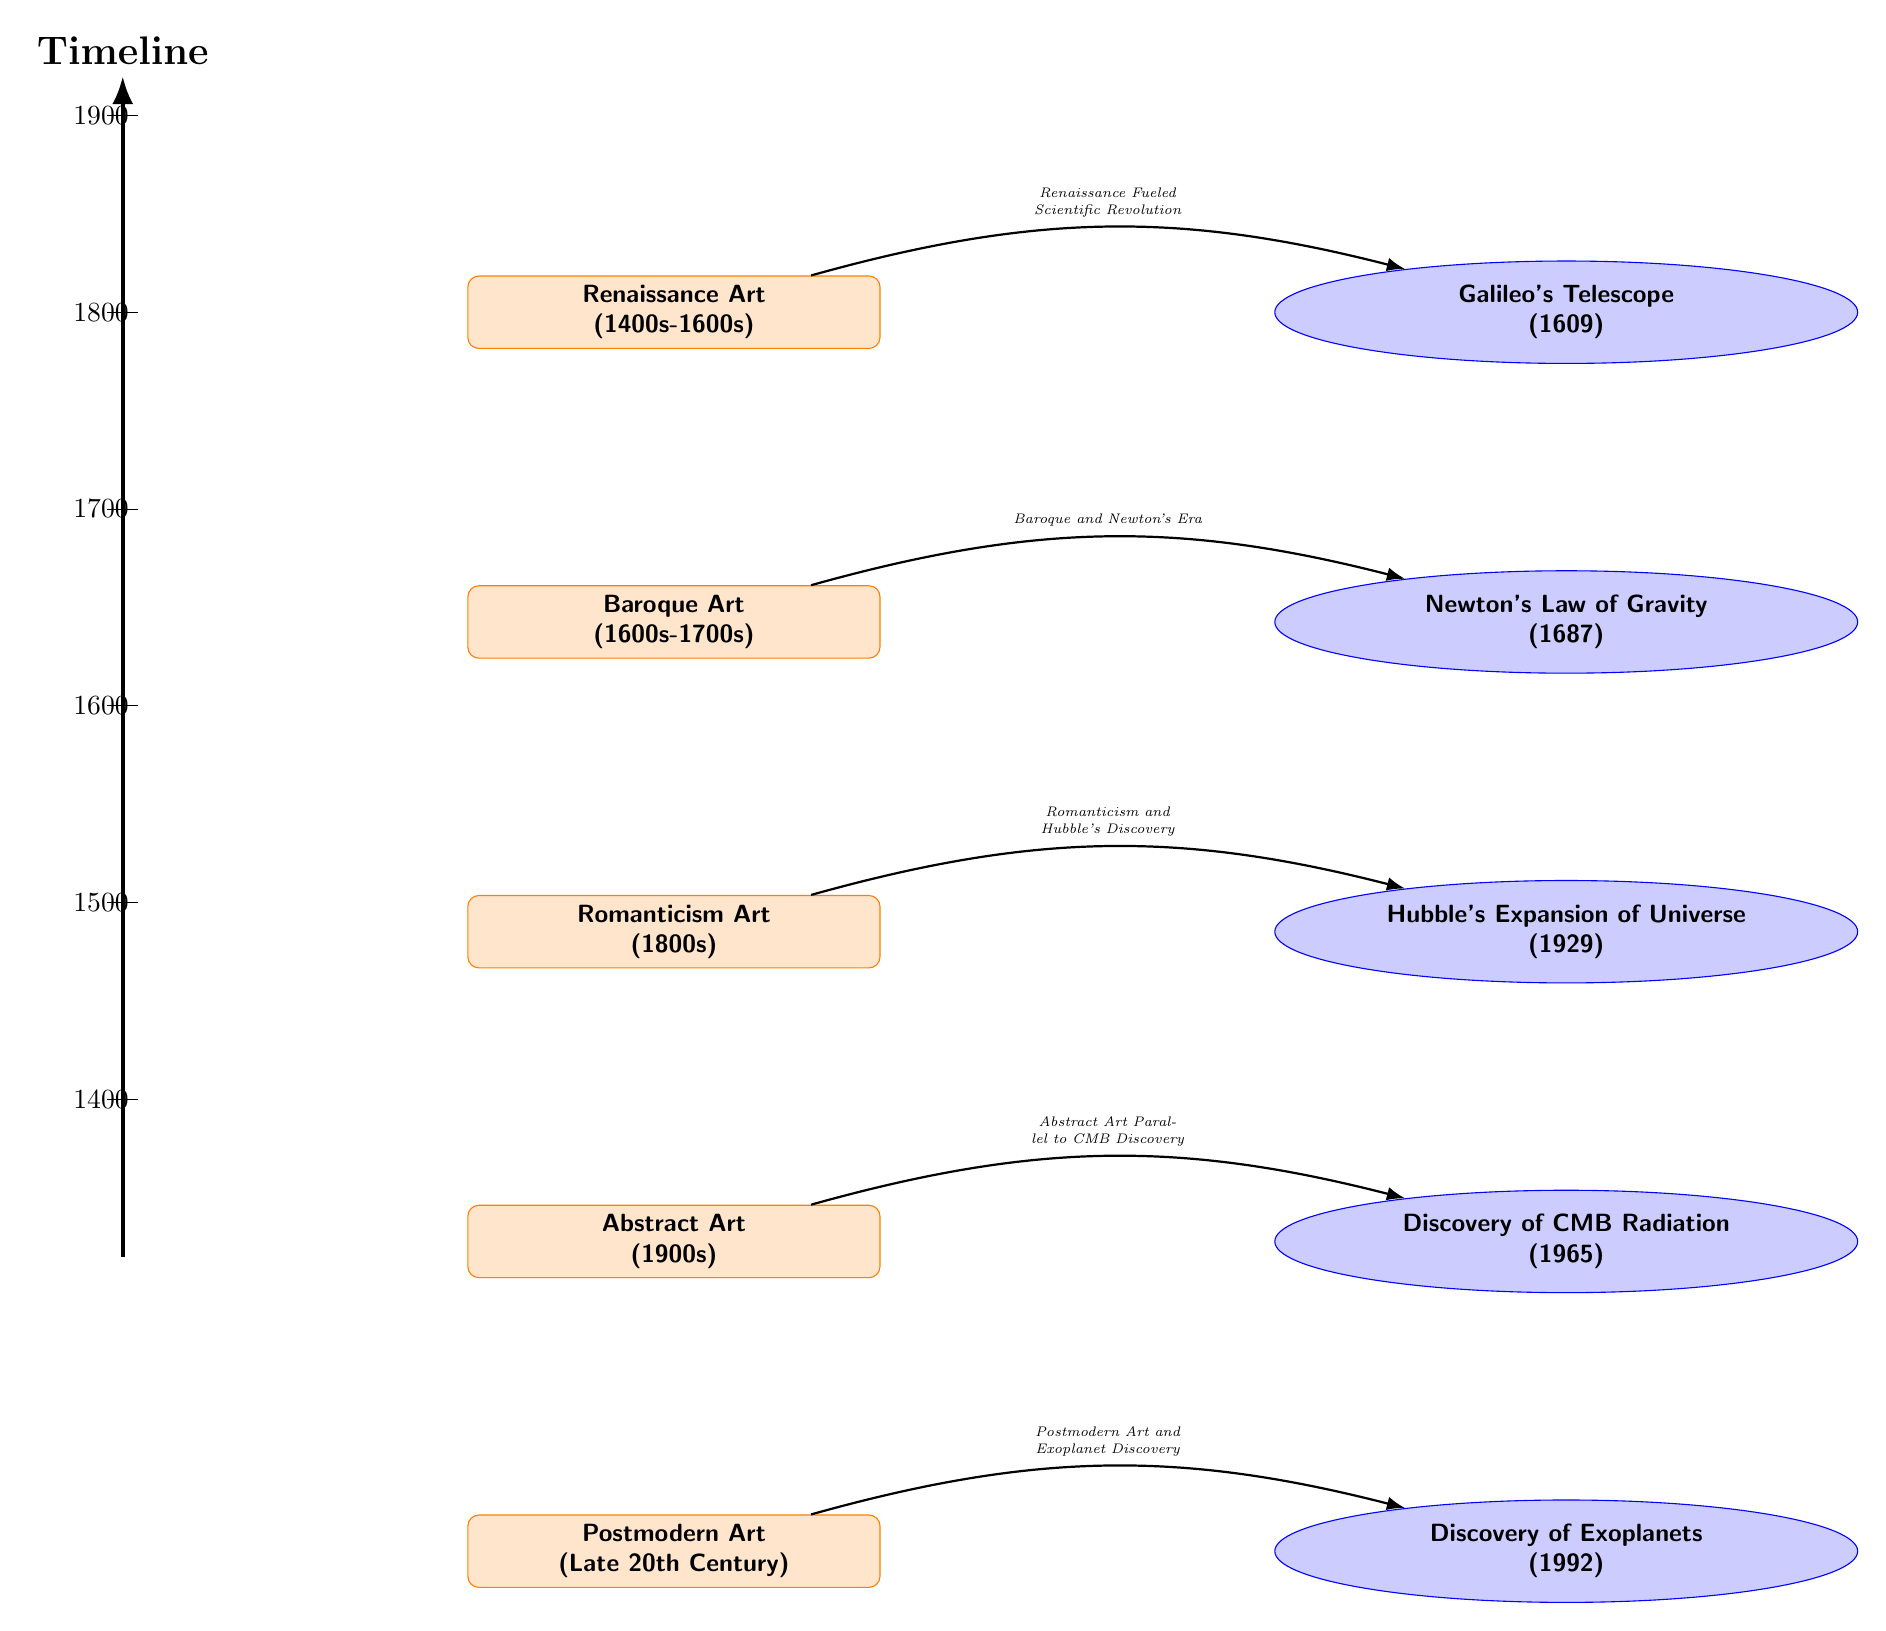What art movement corresponds with Galileo's Telescope? According to the diagram, Galileo's Telescope is connected to the Renaissance Art, which occurred from the 1400s to the 1600s. The edge labeled "Renaissance Fueled Scientific Revolution" indicates this relationship.
Answer: Renaissance Art What year was Newton's Law of Gravity discovered? The diagram specifies that Newton's Law of Gravity was discovered in 1687, which is directly indicated next to the corresponding astronomy node.
Answer: 1687 How many art movements are depicted in the diagram? There are a total of five art movement nodes listed in the diagram, which can be counted: Renaissance, Baroque, Romanticism, Abstract, and Postmodern.
Answer: 5 What does the edge between Romanticism and Hubble's Expansion of Universe represent? The edge labeled "Romanticism and Hubble's Discovery" illustrates the relationship between the Romanticism Art movement and the year 1929, when Hubble's Expansion of Universe was discovered.
Answer: Romanticism and Hubble's Discovery Which astronomical discovery is aligned with Abstract Art? The diagram connects the Discovery of CMB Radiation, which occurred in 1965, with Abstract Art, indicating that this discovery was contemporaneous with the evolution of Abstract Art.
Answer: Discovery of CMB Radiation What timeline year marks the beginning of Baroque Art? The diagram marks the beginning of Baroque Art in the 1600s, which is indicated directly beside the Baroque art node in the diagram.
Answer: 1600s What art movement comes directly before Postmodern Art in the diagram? Directly above the Postmodern Art node in the diagram is the Abstract Art node, which represents the art movement immediately preceding Postmodern Art.
Answer: Abstract Art What does the label associated with the edge from Baroque to Newton indicate? The edge label states "Baroque and Newton's Era," which signifies the historical connection between the period of Baroque Art and the scientific advancements represented by Newton's discoveries.
Answer: Baroque and Newton's Era 